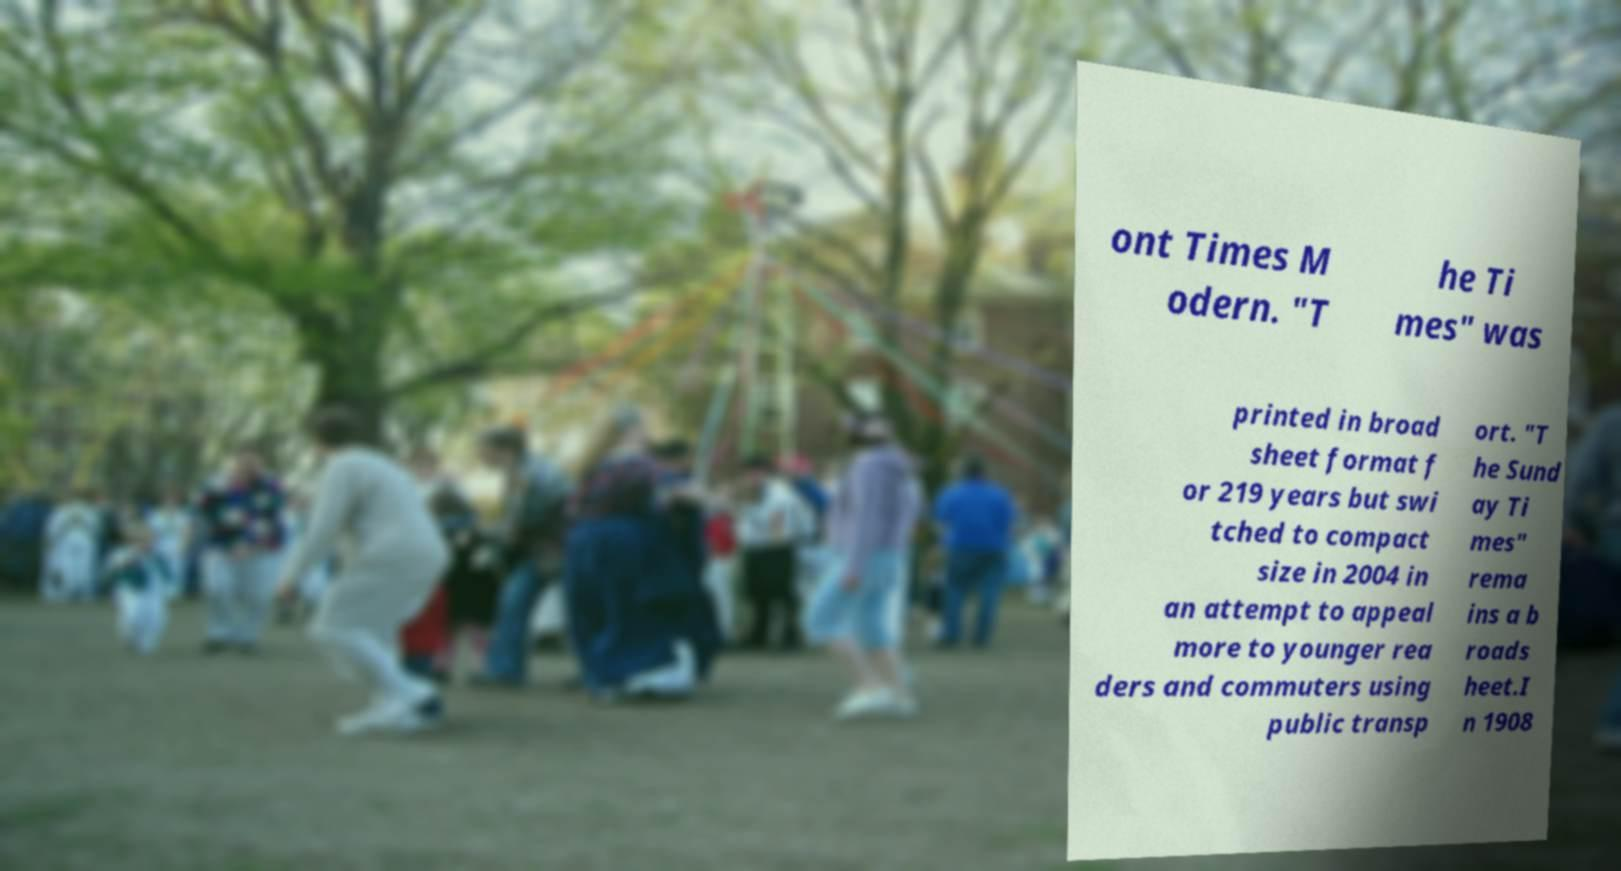There's text embedded in this image that I need extracted. Can you transcribe it verbatim? ont Times M odern. "T he Ti mes" was printed in broad sheet format f or 219 years but swi tched to compact size in 2004 in an attempt to appeal more to younger rea ders and commuters using public transp ort. "T he Sund ay Ti mes" rema ins a b roads heet.I n 1908 